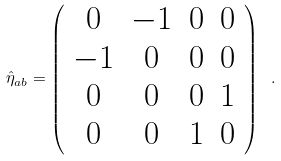<formula> <loc_0><loc_0><loc_500><loc_500>\hat { \eta } _ { a b } = \left ( \begin{array} { c c c c } 0 & - 1 & 0 & 0 \\ - 1 & 0 & 0 & 0 \\ 0 & 0 & 0 & 1 \\ 0 & 0 & 1 & 0 \end{array} \right ) \ .</formula> 